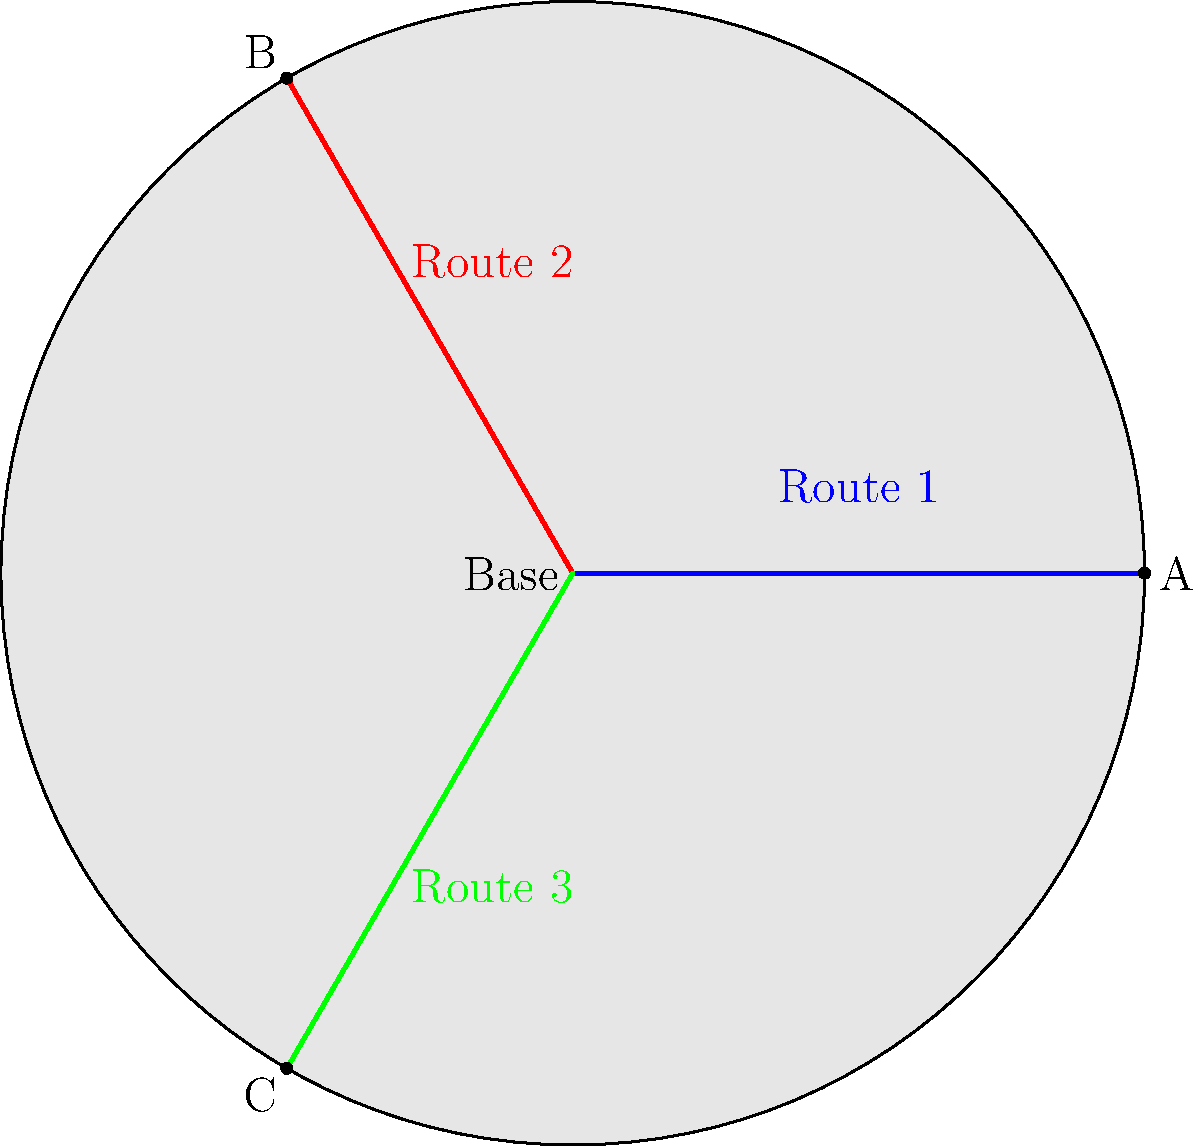Given a battlefield map with three potential routes to critical checkpoints A, B, and C, which route would you prioritize for a small, elite team tasked with gathering intelligence, considering that enemy forces are known to heavily patrol the eastern sector? 1. Analyze the map:
   - Route 1 (blue) leads to checkpoint A in the east
   - Route 2 (red) leads to checkpoint B in the northwest
   - Route 3 (green) leads to checkpoint C in the southwest

2. Consider the given information:
   - The team is small and elite, suggesting a need for stealth and efficiency
   - Enemy forces heavily patrol the eastern sector

3. Evaluate each route:
   - Route 1 is the most direct but goes through the heavily patrolled eastern sector
   - Route 2 avoids the eastern sector and provides access to the northwest
   - Route 3 also avoids the eastern sector and provides access to the southwest

4. Strategic considerations:
   - Avoiding enemy detection is crucial for intelligence gathering
   - The northwest and southwest sectors likely have less enemy presence

5. Decision-making process:
   - Eliminate Route 1 due to high risk of enemy encounter
   - Choose between Routes 2 and 3 based on potential intelligence value
   - Route 2 (northwest) often provides better vantage points for observation

6. Final assessment:
   Route 2 offers the best balance of safety and strategic advantage for intelligence gathering.
Answer: Route 2 (northwest) 